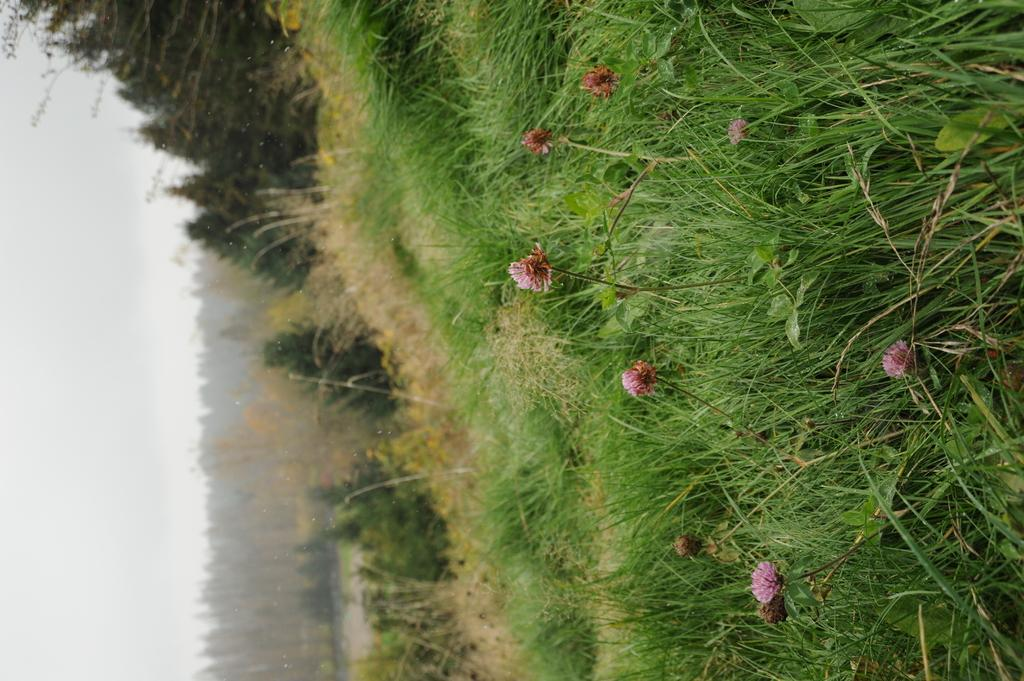What type of landscape is depicted in the image? There is a grassland in the image. What features can be found in the grassland? The grassland has plants and trees. Where are the plants with flowers located in the image? The plants with flowers are on the right side of the image. Where are the trees located in the image? The trees are in the middle of the image. What is visible on the left side of the image? The sky is visible on the left side of the image. How many cats can be seen playing with a rat in the grassland? There are no cats or rats present in the image; it features a grassland with plants and trees. What type of rod is used to measure the depth of the grassland? There is no rod present in the image, and the depth of the grassland is not relevant to the description of the image. 